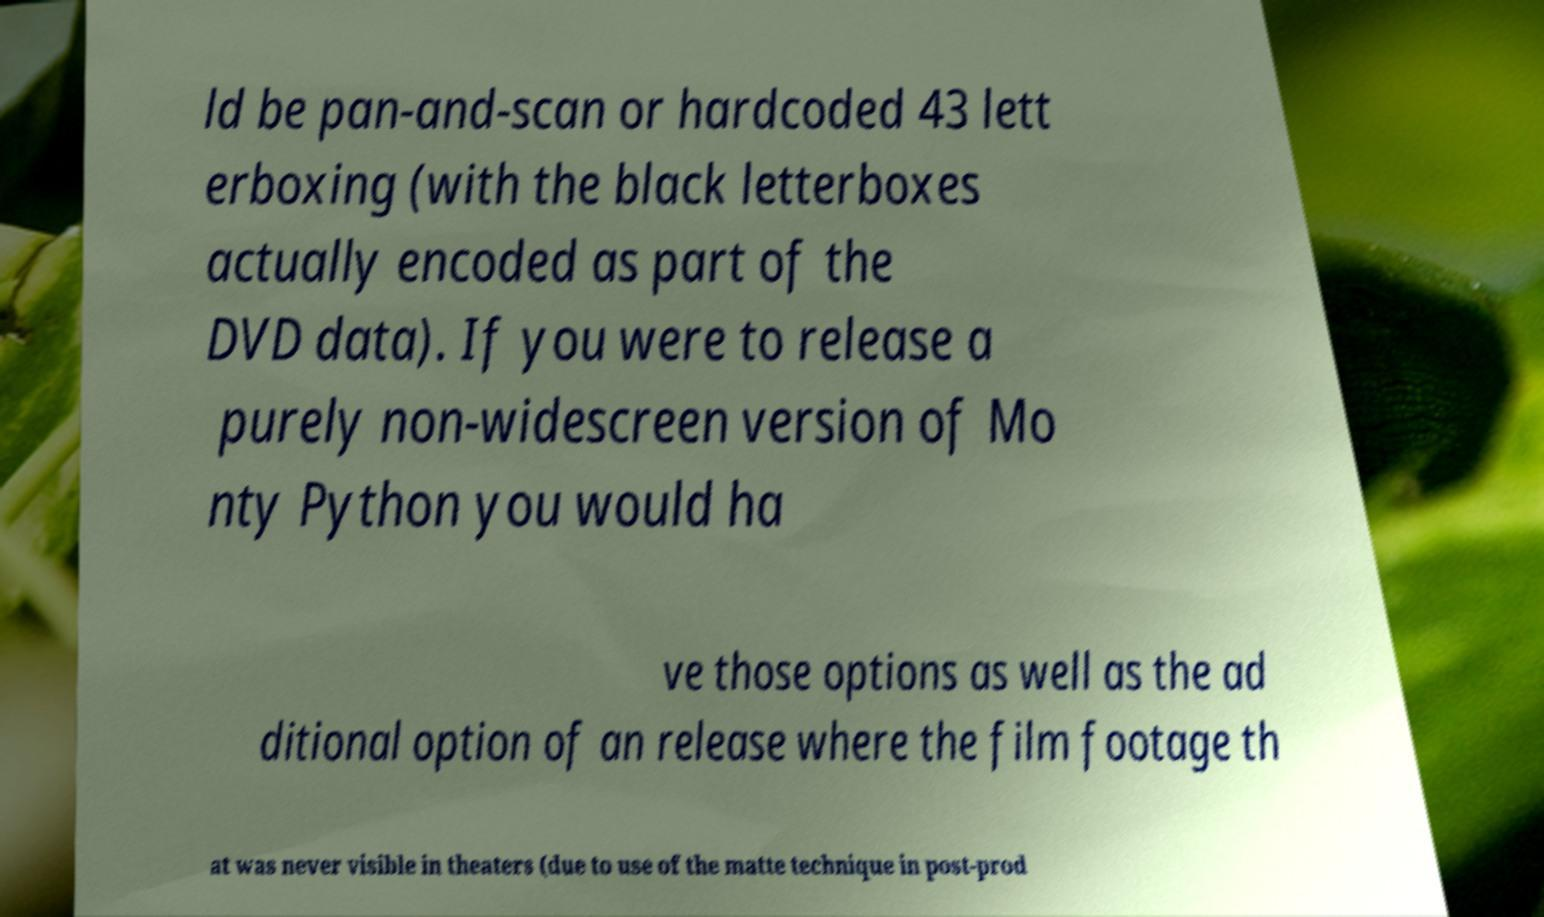Please read and relay the text visible in this image. What does it say? ld be pan-and-scan or hardcoded 43 lett erboxing (with the black letterboxes actually encoded as part of the DVD data). If you were to release a purely non-widescreen version of Mo nty Python you would ha ve those options as well as the ad ditional option of an release where the film footage th at was never visible in theaters (due to use of the matte technique in post-prod 